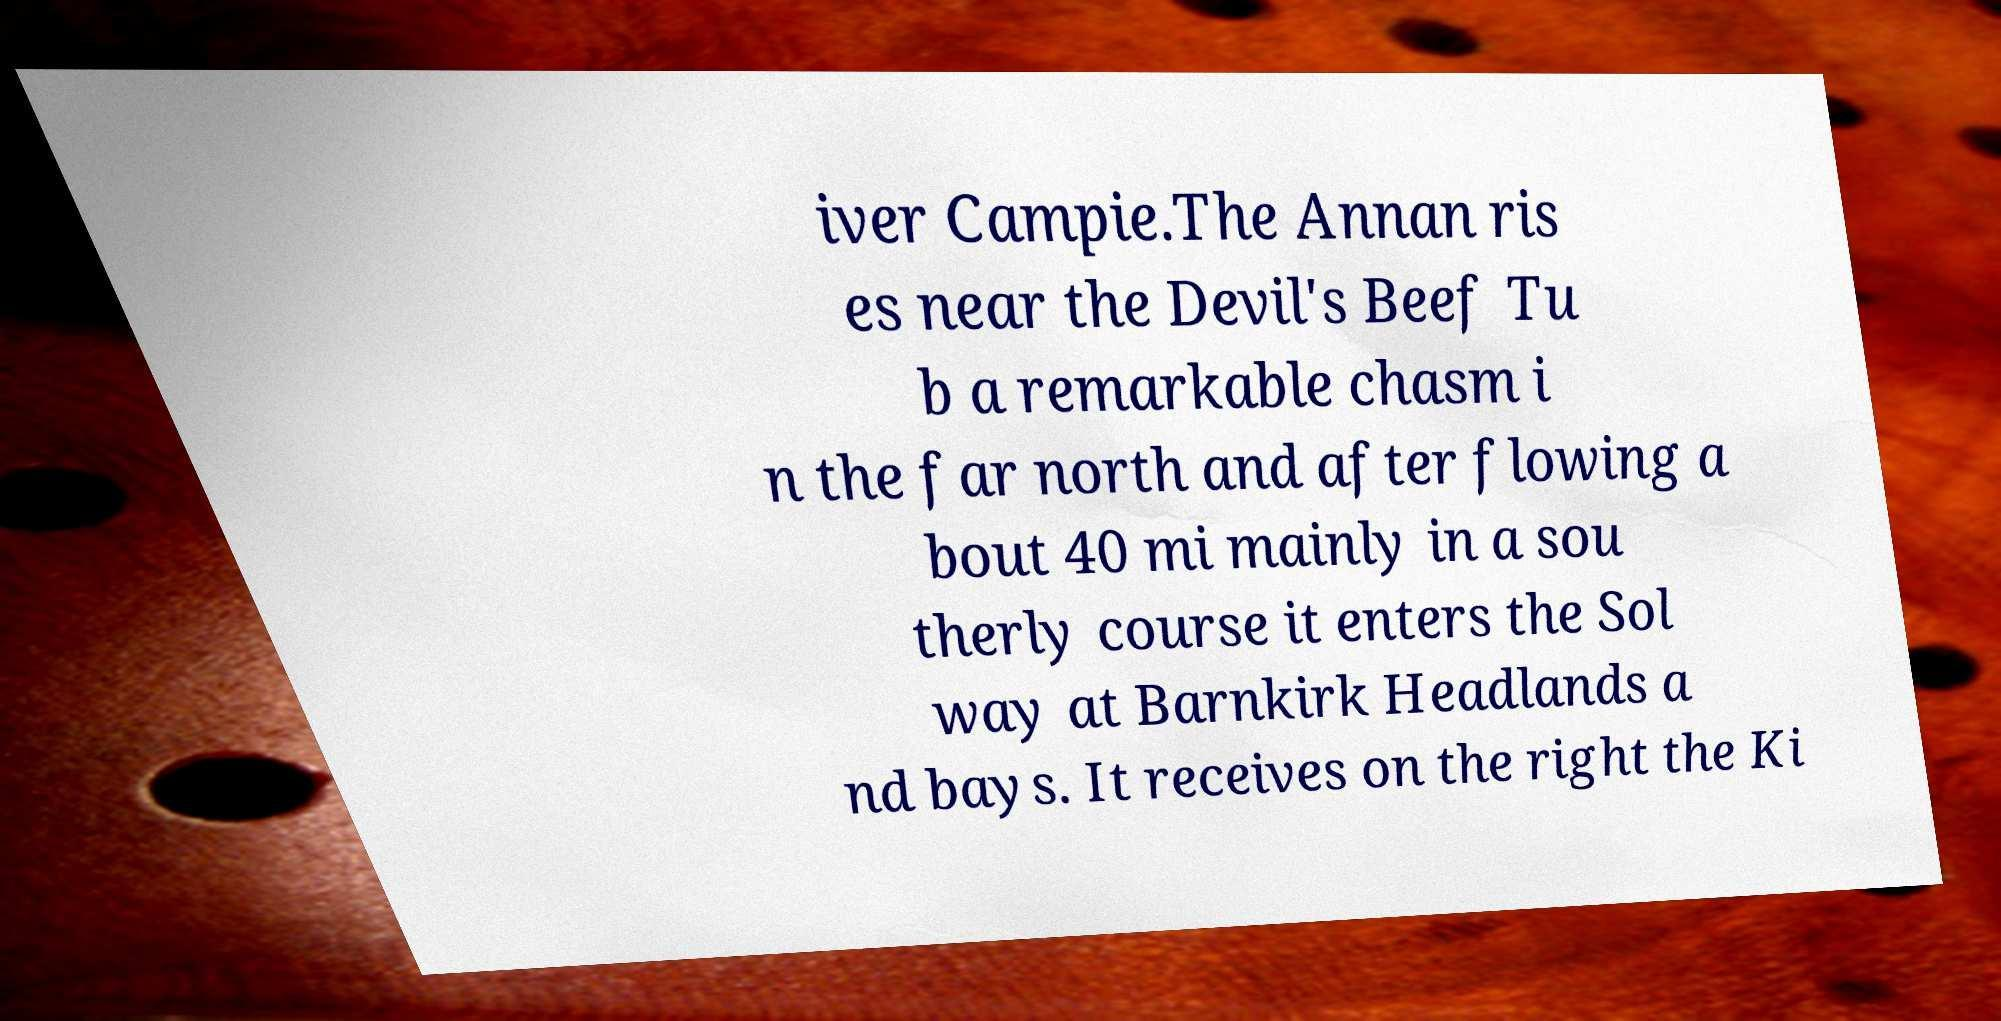There's text embedded in this image that I need extracted. Can you transcribe it verbatim? iver Campie.The Annan ris es near the Devil's Beef Tu b a remarkable chasm i n the far north and after flowing a bout 40 mi mainly in a sou therly course it enters the Sol way at Barnkirk Headlands a nd bays. It receives on the right the Ki 